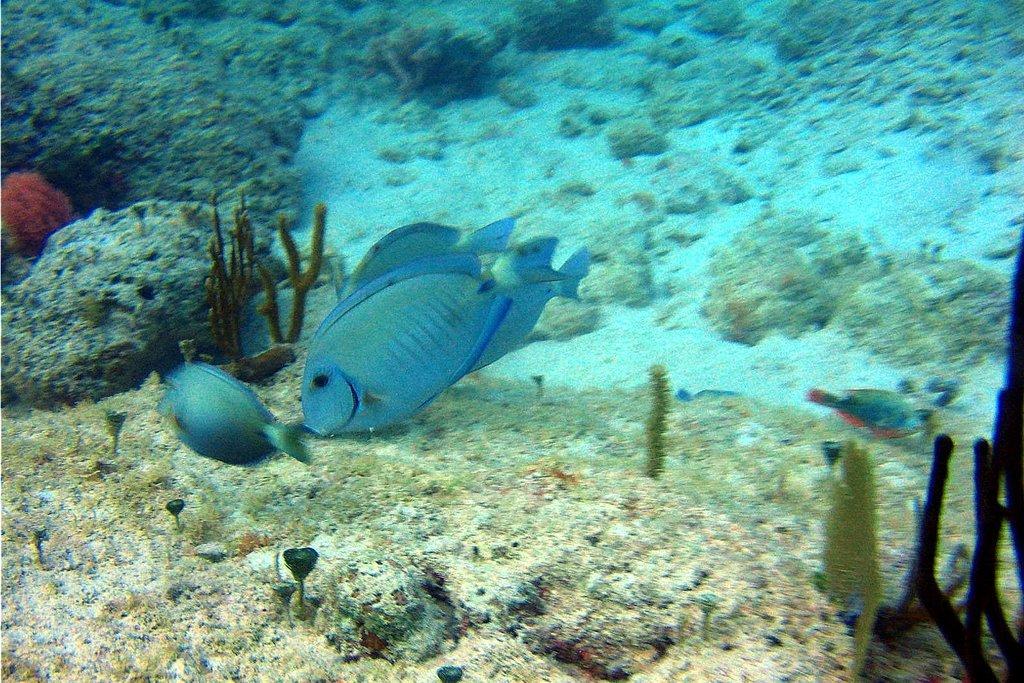Please provide a concise description of this image. It is the picture of underground surface of the water, there are small fishes and other plants. 